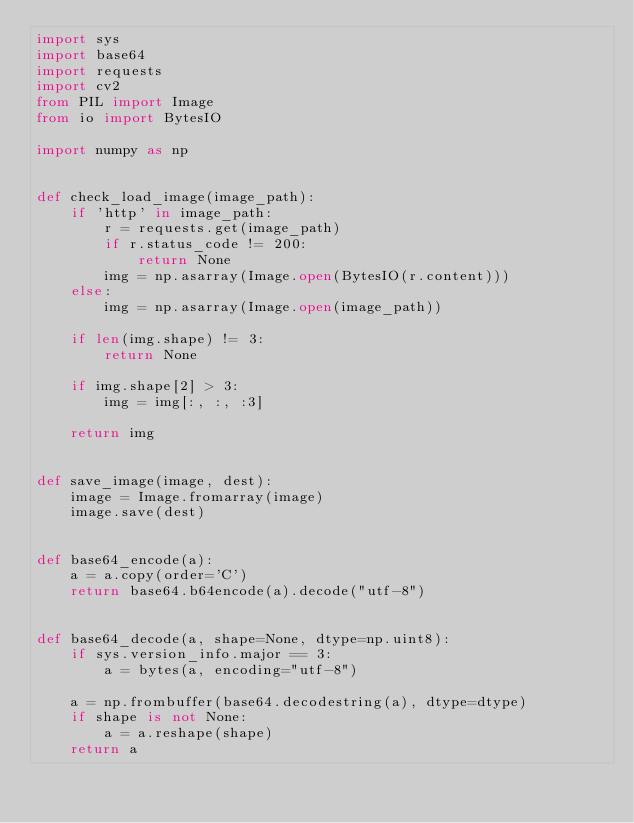<code> <loc_0><loc_0><loc_500><loc_500><_Python_>import sys
import base64
import requests
import cv2
from PIL import Image
from io import BytesIO

import numpy as np


def check_load_image(image_path):
    if 'http' in image_path:
        r = requests.get(image_path)
        if r.status_code != 200:
            return None
        img = np.asarray(Image.open(BytesIO(r.content)))
    else:
        img = np.asarray(Image.open(image_path))

    if len(img.shape) != 3:
        return None

    if img.shape[2] > 3:
        img = img[:, :, :3]

    return img


def save_image(image, dest):
    image = Image.fromarray(image)
    image.save(dest)


def base64_encode(a):
    a = a.copy(order='C')
    return base64.b64encode(a).decode("utf-8")


def base64_decode(a, shape=None, dtype=np.uint8):
    if sys.version_info.major == 3:
        a = bytes(a, encoding="utf-8")

    a = np.frombuffer(base64.decodestring(a), dtype=dtype)
    if shape is not None:
        a = a.reshape(shape)
    return a
</code> 